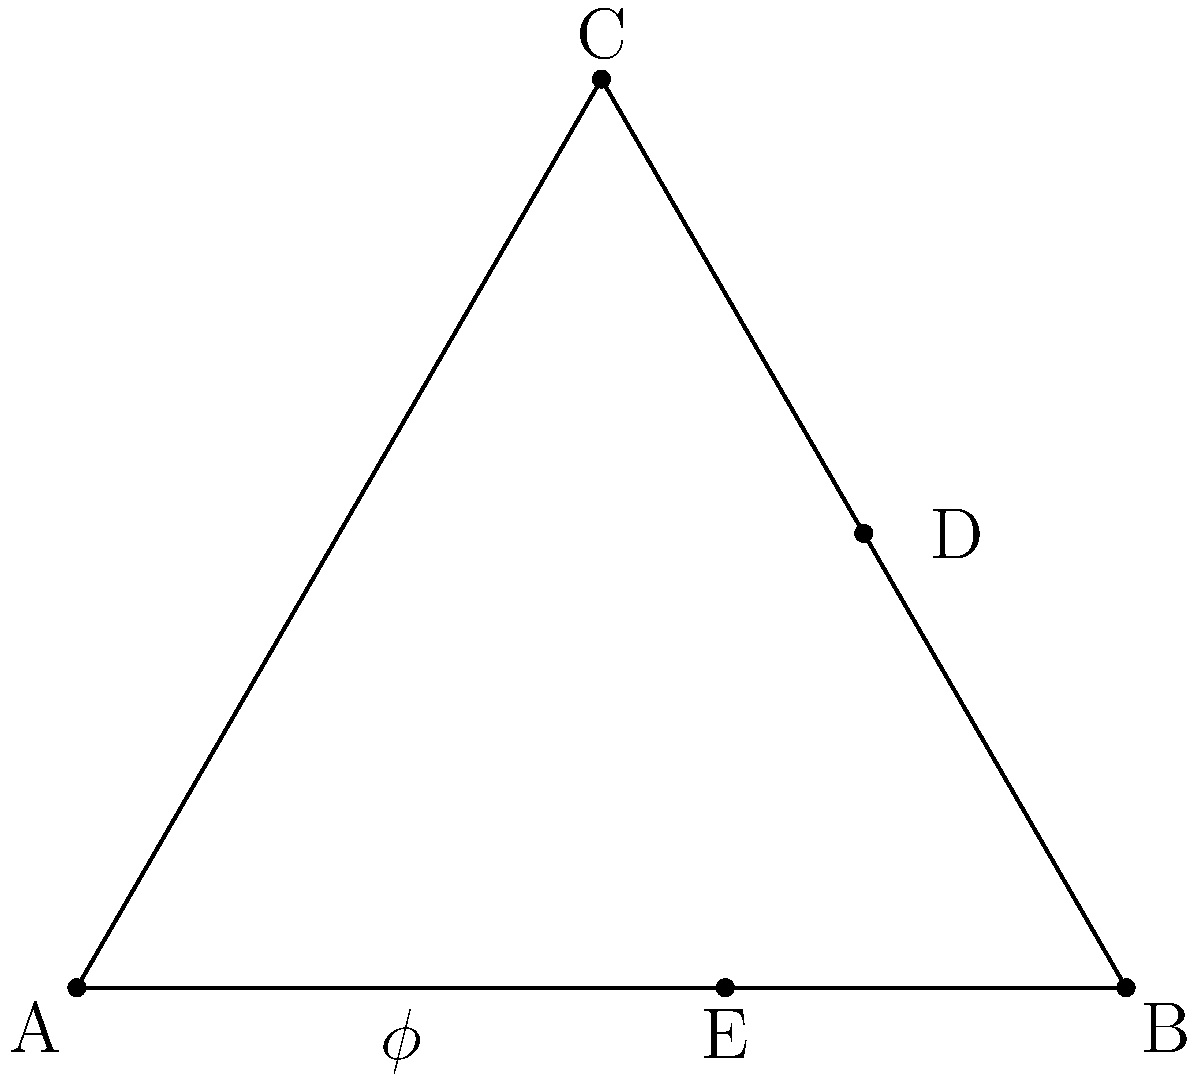In the sacred triangle ABC, point E divides AB in the golden ratio. If CD is the altitude to AB, and D is the midpoint of BC, what is the ratio of AE to EB, expressed as a decimal to 3 decimal places? To solve this problem, we need to understand the golden ratio and its properties:

1. The golden ratio, denoted by $\phi$ (phi), is approximately equal to 1.618033988749895.

2. In the golden ratio, the ratio of the larger part to the smaller part is equal to the ratio of the whole to the larger part.

3. Mathematically, this can be expressed as: $\frac{a+b}{a} = \frac{a}{b} = \phi$

4. The reciprocal of $\phi$ is $\frac{1}{\phi} = \phi - 1 \approx 0.618033988749895$

In our triangle:
- AE is the larger part
- EB is the smaller part
- AB is the whole

The ratio of AE to EB is exactly $\phi : 1$

To calculate this as a decimal:
$\frac{AE}{EB} = \phi \approx 1.618033988749895$

Rounding to 3 decimal places: 1.618
Answer: 1.618 